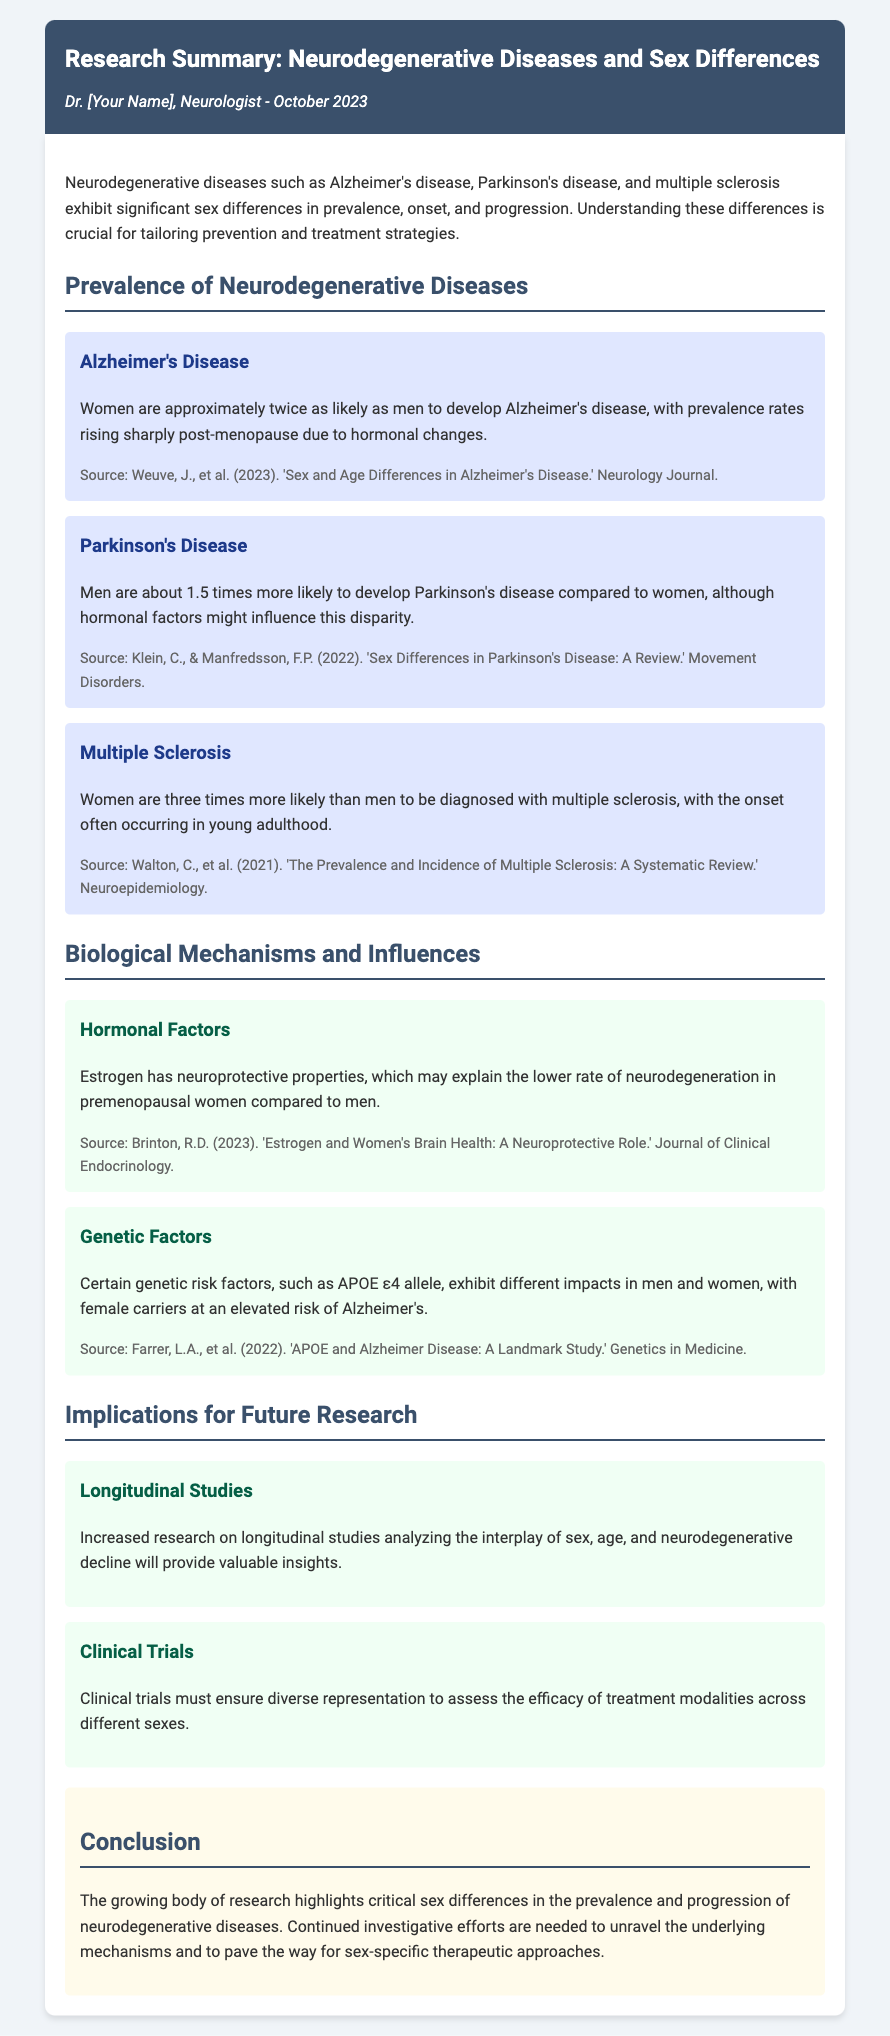What are the three neurodegenerative diseases discussed? The document lists Alzheimer's disease, Parkinson's disease, and multiple sclerosis as the neurodegenerative diseases discussed.
Answer: Alzheimer's disease, Parkinson's disease, multiple sclerosis What is the prevalence of Alzheimer's disease in women compared to men? The document states that women are approximately twice as likely as men to develop Alzheimer's disease.
Answer: Twice as likely How much more likely are men to develop Parkinson's disease compared to women? The document indicates that men are about 1.5 times more likely to develop Parkinson's disease than women.
Answer: 1.5 times What factor is discussed as having neuroprotective properties in women? The document mentions estrogen as having neuroprotective properties.
Answer: Estrogen Which genetic risk factor is associated with an elevated risk of Alzheimer's in female carriers? The document refers to the APOE ε4 allele as a genetic risk factor associated with Alzheimer's in female carriers.
Answer: APOE ε4 allele What type of studies does the document suggest for future research? The document calls for increased research on longitudinal studies analyzing the interplay of sex, age, and neurodegenerative decline.
Answer: Longitudinal studies What is a key implication for clinical trials discussed in the document? The document emphasizes the need for diverse representation in clinical trials to assess treatment efficacy across different sexes.
Answer: Diverse representation What hormonal change is associated with the rising prevalence of Alzheimer's in women? The document states that prevalence rates rise sharply post-menopause due to hormonal changes.
Answer: Post-menopause What is the overall conclusion regarding sex differences in neurodegenerative diseases? The conclusion highlights critical sex differences in prevalence and progression, stating that continued research is needed for sex-specific therapeutic approaches.
Answer: Sex-specific therapeutic approaches 